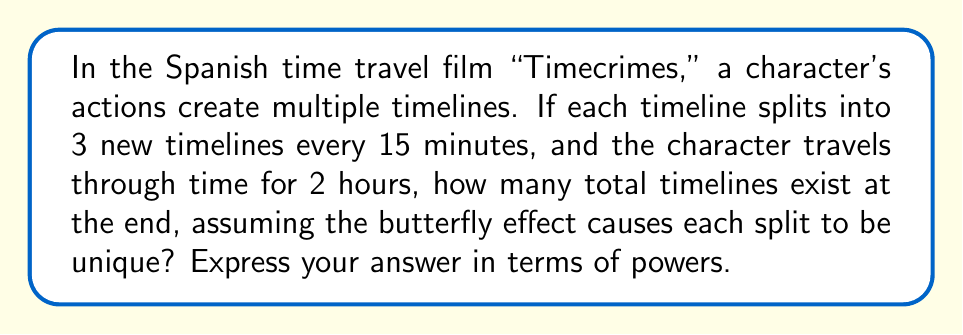Could you help me with this problem? Let's approach this step-by-step:

1) First, we need to calculate how many 15-minute intervals are in 2 hours:
   $$ \frac{2 \text{ hours}}{15 \text{ minutes}} = \frac{120 \text{ minutes}}{15 \text{ minutes}} = 8 \text{ intervals} $$

2) Now, we can think of this as a tree structure where each node splits into 3 branches every 15 minutes.

3) At the start, we have 1 timeline.

4) After 15 minutes (1st split):
   $$ 1 * 3 = 3 \text{ timelines} $$

5) After 30 minutes (2nd split):
   $$ 3 * 3 = 3^2 = 9 \text{ timelines} $$

6) We can see a pattern forming. After each split, the number of timelines is multiplied by 3.

7) Since there are 8 intervals in total, the final number of timelines will be:
   $$ 3^8 \text{ timelines} $$

This exponential growth demonstrates the butterfly effect in chaos theory, where small changes can lead to dramatically different outcomes over time.
Answer: $3^8$ 